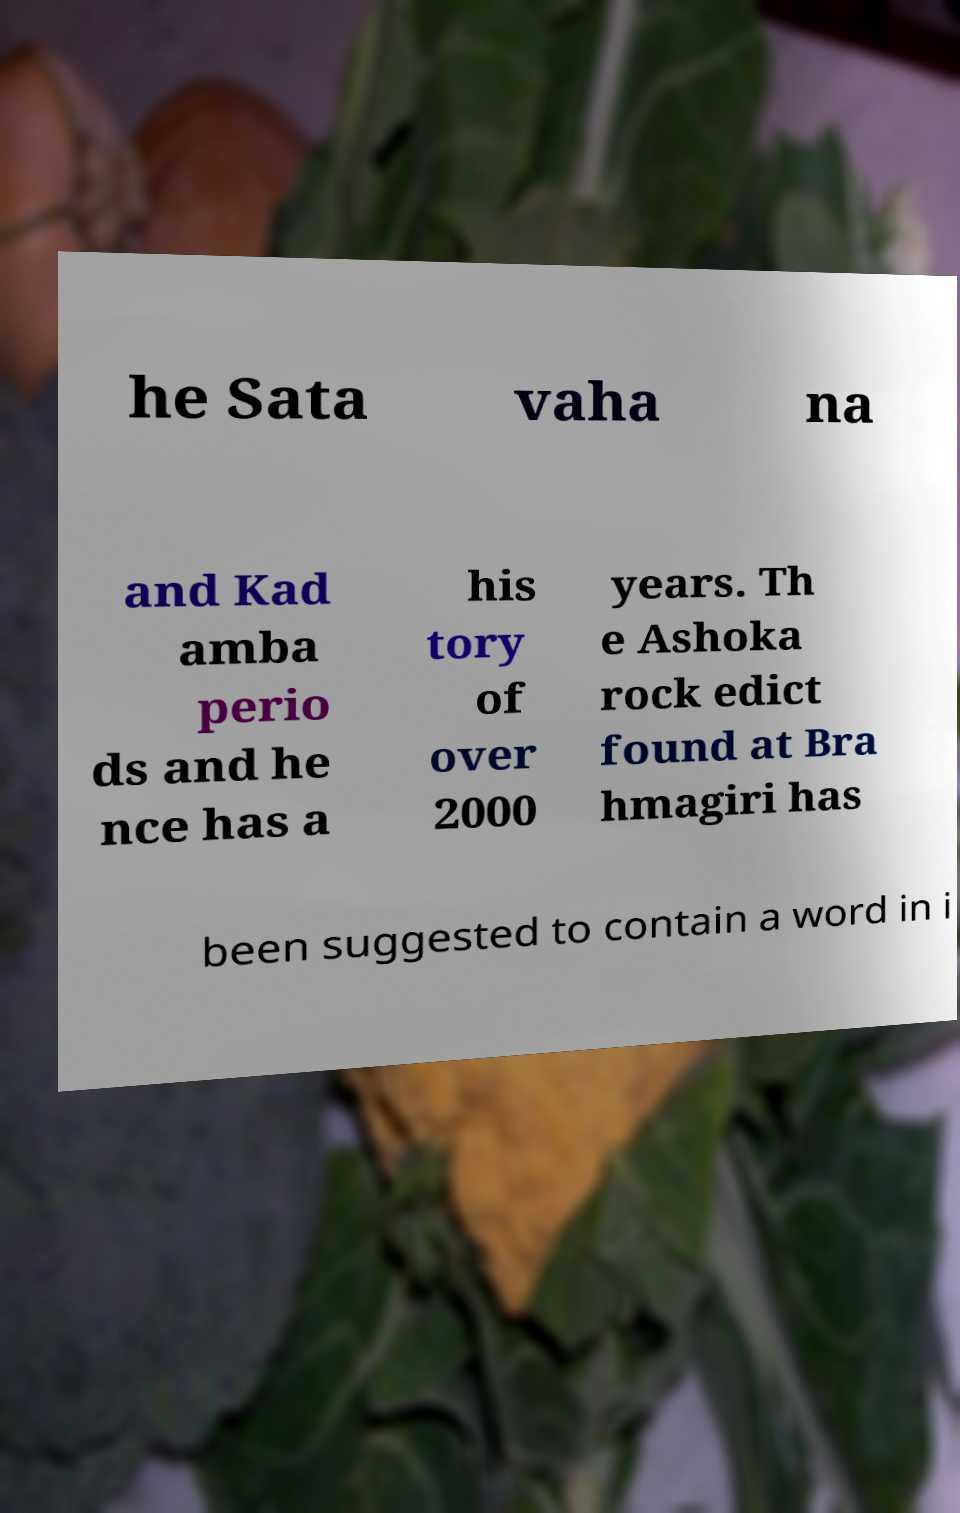What messages or text are displayed in this image? I need them in a readable, typed format. he Sata vaha na and Kad amba perio ds and he nce has a his tory of over 2000 years. Th e Ashoka rock edict found at Bra hmagiri has been suggested to contain a word in i 